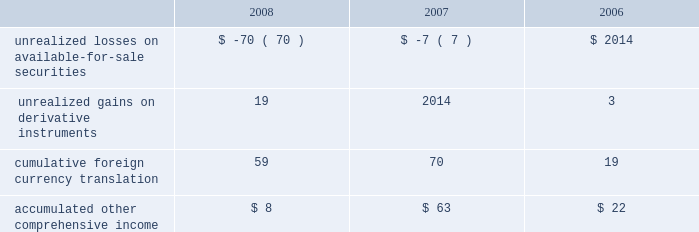Table of contents notes to consolidated financial statements ( continued ) note 6 2014shareholders 2019 equity preferred stock the company has five million shares of authorized preferred stock , none of which is issued or outstanding .
Under the terms of the company 2019s restated articles of incorporation , the board of directors is authorized to determine or alter the rights , preferences , privileges and restrictions of the company 2019s authorized but unissued shares of preferred stock .
Ceo restricted stock award on march 19 , 2003 , the company 2019s board of directors granted 10 million shares of restricted stock to the company 2019s ceo that vested on march 19 , 2006 .
The amount of the restricted stock award expensed by the company was based on the closing market price of the company 2019s common stock on the date of grant and was amortized ratably on a straight-line basis over the three-year requisite service period .
Upon vesting during 2006 , the 10 million shares of restricted stock had a fair value of $ 646.6 million and had grant-date fair value of $ 7.48 per share .
The restricted stock award was net-share settled such that the company withheld shares with value equivalent to the ceo 2019s minimum statutory obligation for the applicable income and other employment taxes , and remitted the cash to the appropriate taxing authorities .
The total shares withheld of 4.6 million were based on the value of the restricted stock award on the vesting date as determined by the company 2019s closing stock price of $ 64.66 .
The remaining shares net of those withheld were delivered to the company 2019s ceo .
Total payments for the ceo 2019s tax obligations to the taxing authorities was $ 296 million in 2006 and are reflected as a financing activity within the consolidated statements of cash flows .
The net-share settlement had the effect of share repurchases by the company as it reduced and retired the number of shares outstanding and did not represent an expense to the company .
The company 2019s ceo has no remaining shares of restricted stock .
For the year ended september 30 , 2006 , compensation expense related to restricted stock was $ 4.6 million .
Comprehensive income comprehensive income consists of two components , net income and other comprehensive income .
Other comprehensive income refers to revenue , expenses , gains , and losses that under u.s .
Generally accepted accounting principles are recorded as an element of shareholders 2019 equity but are excluded from net income .
The company 2019s other comprehensive income consists of foreign currency translation adjustments from those subsidiaries not using the u.s .
Dollar as their functional currency , unrealized gains and losses on marketable securities categorized as available- for-sale , and net deferred gains and losses on certain derivative instruments accounted for as cash flow hedges .
The table summarizes the components of accumulated other comprehensive income , net of taxes , as of the three fiscal years ended september 27 , 2008 ( in millions ) : the change in fair value of available-for-sale securities included in other comprehensive income was $ ( 63 ) million , $ ( 7 ) million , and $ 4 million , net of taxes in 2008 , 2007 , and 2006 , respectively .
The tax effect related to the change in unrealized gain/loss on available-for-sale securities was $ 42 million , $ 4 million , and $ ( 2 ) million for 2008 , 2007 , and 2006 , respectively. .

What was the greatest annual amount in millions of cumulative foreign currency translation? 
Computations: table_max(cumulative foreign currency translation, none)
Answer: 70.0. 